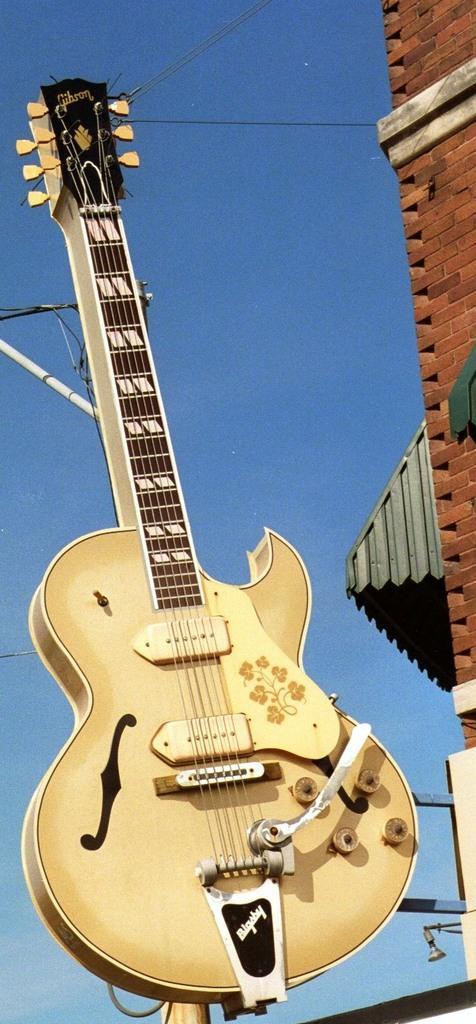Could you give a brief overview of what you see in this image? In the center of the image, we can see a guitar and in the background, there is a building and we can see a pole along with wires. 